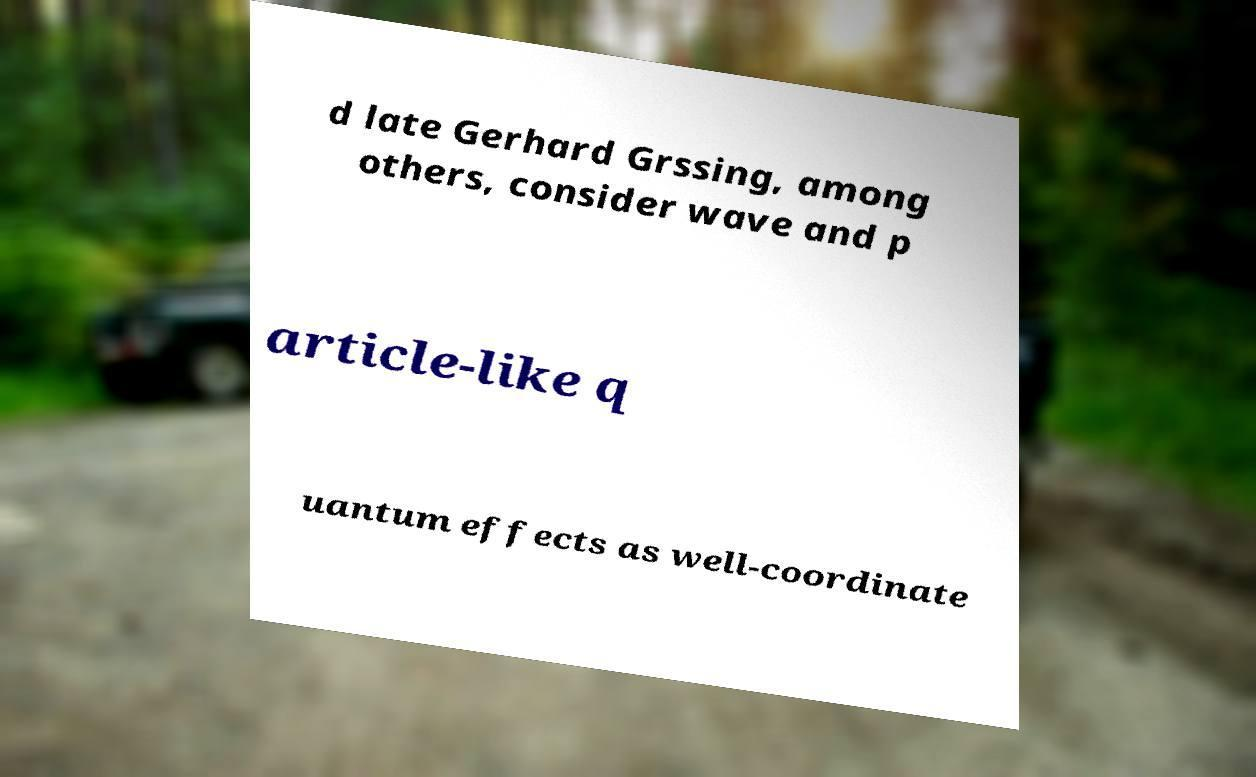Please read and relay the text visible in this image. What does it say? d late Gerhard Grssing, among others, consider wave and p article-like q uantum effects as well-coordinate 